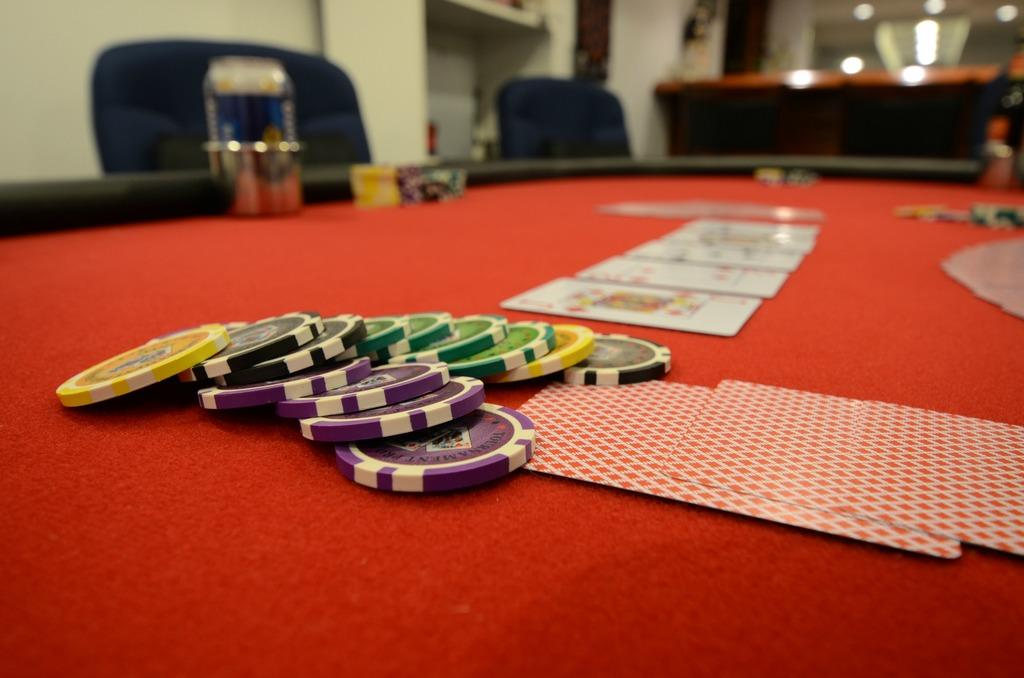What is the main object in the image? There is a table in the image. What is on the table? There are cards and coins on the table. What might be used for sitting around the table? There are chairs around the table. Can you describe the background of the image? The background of the image is blurred. What is the mass of the distribution of office supplies in the image? There is no mention of office supplies in the image, so it is not possible to determine their mass or distribution. 